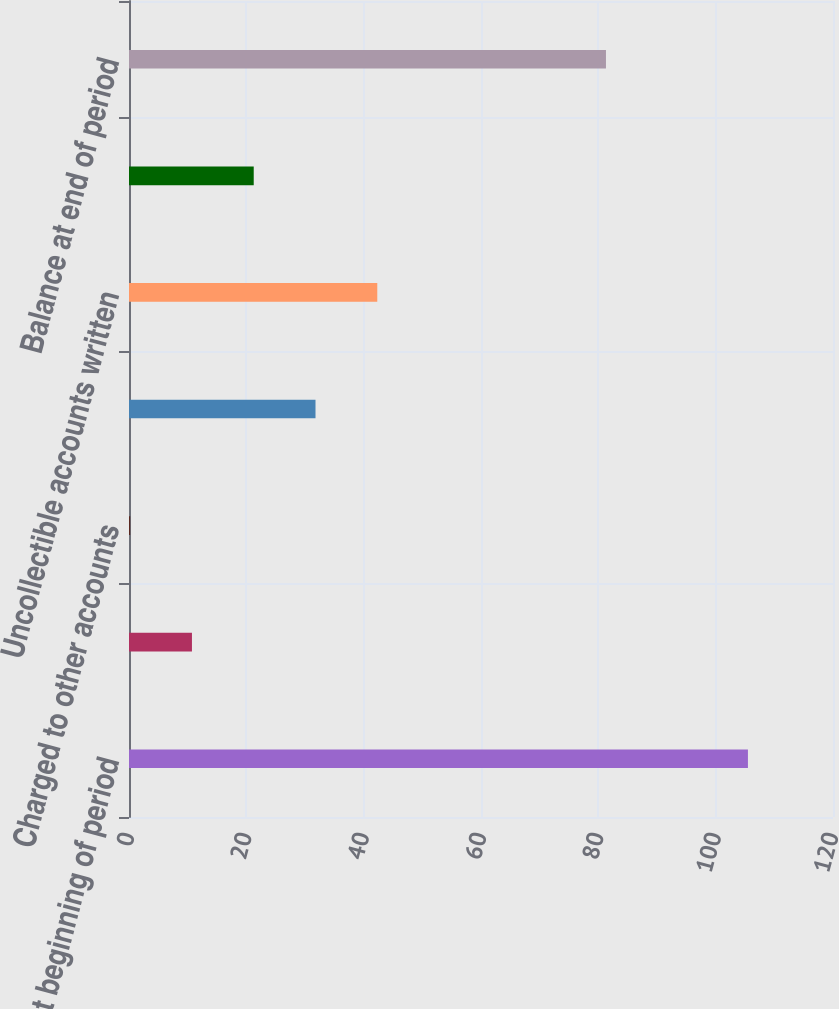<chart> <loc_0><loc_0><loc_500><loc_500><bar_chart><fcel>Balance at beginning of period<fcel>Charged to costs and expenses<fcel>Charged to other accounts<fcel>Dispositions<fcel>Uncollectible accounts written<fcel>Foreign currency translation<fcel>Balance at end of period<nl><fcel>105.5<fcel>10.73<fcel>0.2<fcel>31.79<fcel>42.32<fcel>21.26<fcel>81.3<nl></chart> 